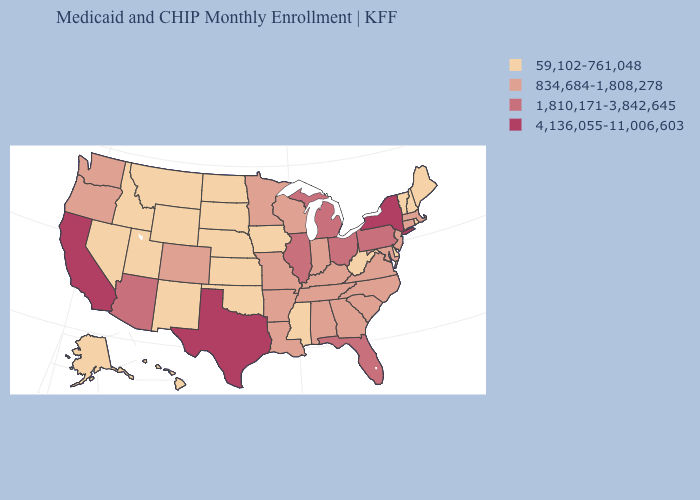Does the first symbol in the legend represent the smallest category?
Quick response, please. Yes. What is the value of Massachusetts?
Short answer required. 834,684-1,808,278. Which states hav the highest value in the Northeast?
Give a very brief answer. New York. Name the states that have a value in the range 834,684-1,808,278?
Concise answer only. Alabama, Arkansas, Colorado, Connecticut, Georgia, Indiana, Kentucky, Louisiana, Maryland, Massachusetts, Minnesota, Missouri, New Jersey, North Carolina, Oregon, South Carolina, Tennessee, Virginia, Washington, Wisconsin. Does Kentucky have the highest value in the South?
Be succinct. No. What is the highest value in states that border Minnesota?
Quick response, please. 834,684-1,808,278. Which states hav the highest value in the Northeast?
Quick response, please. New York. Is the legend a continuous bar?
Short answer required. No. Which states have the highest value in the USA?
Be succinct. California, New York, Texas. Does Colorado have a higher value than Minnesota?
Short answer required. No. Which states hav the highest value in the MidWest?
Give a very brief answer. Illinois, Michigan, Ohio. What is the value of Idaho?
Be succinct. 59,102-761,048. What is the value of Tennessee?
Write a very short answer. 834,684-1,808,278. Name the states that have a value in the range 4,136,055-11,006,603?
Short answer required. California, New York, Texas. Name the states that have a value in the range 1,810,171-3,842,645?
Short answer required. Arizona, Florida, Illinois, Michigan, Ohio, Pennsylvania. 